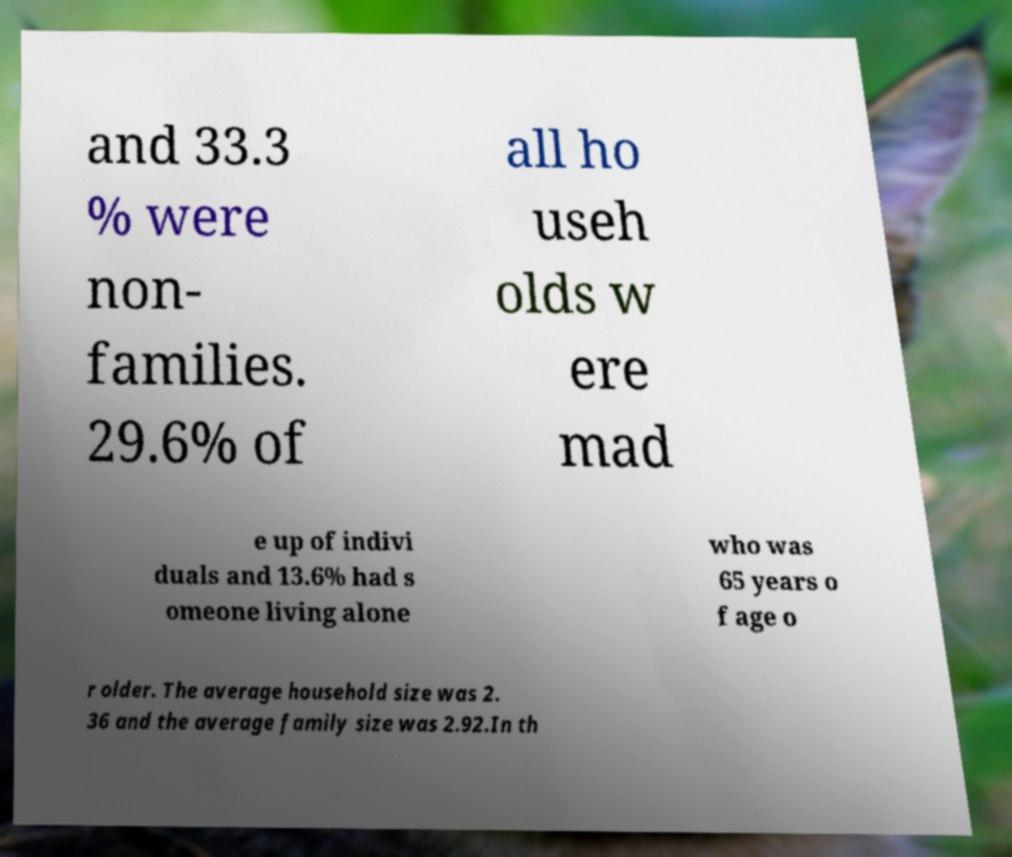I need the written content from this picture converted into text. Can you do that? and 33.3 % were non- families. 29.6% of all ho useh olds w ere mad e up of indivi duals and 13.6% had s omeone living alone who was 65 years o f age o r older. The average household size was 2. 36 and the average family size was 2.92.In th 